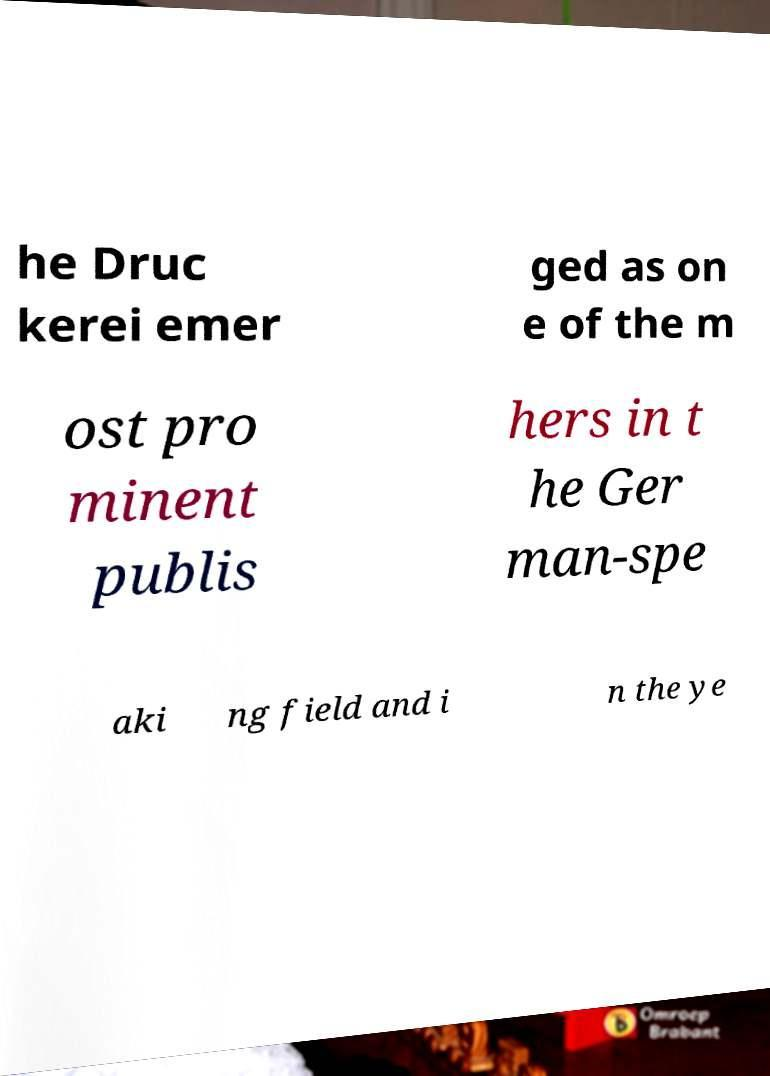I need the written content from this picture converted into text. Can you do that? he Druc kerei emer ged as on e of the m ost pro minent publis hers in t he Ger man-spe aki ng field and i n the ye 